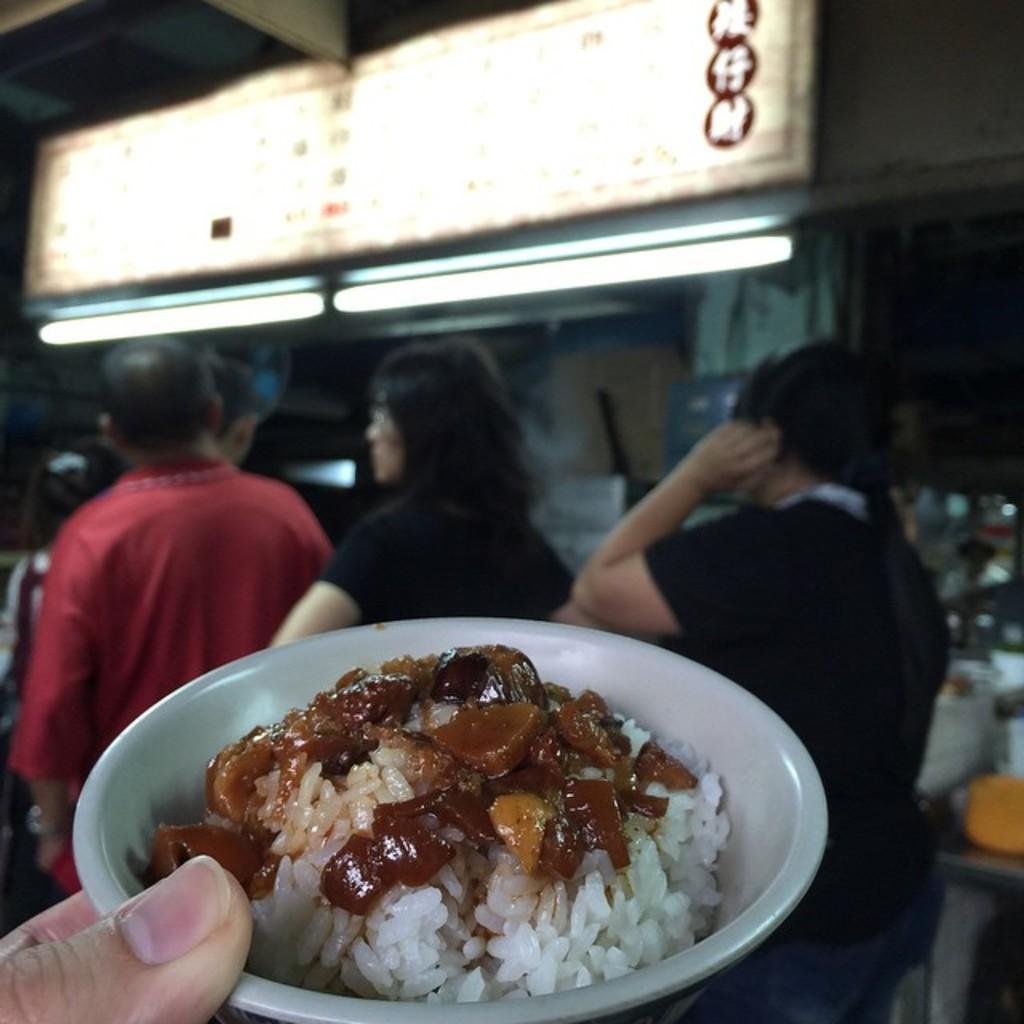Could you give a brief overview of what you see in this image? In this image we can see food item in a bowl in the person's fingers. In the background we can see few persons, lights, hoarding and objects. 